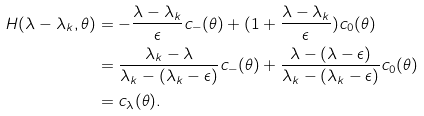<formula> <loc_0><loc_0><loc_500><loc_500>H ( \lambda - \lambda _ { k } , \theta ) & = - \frac { \lambda - \lambda _ { k } } { \epsilon } c _ { - } ( \theta ) + ( 1 + \frac { \lambda - \lambda _ { k } } { \epsilon } ) c _ { 0 } ( \theta ) \\ & = \frac { \lambda _ { k } - \lambda } { \lambda _ { k } - ( \lambda _ { k } - \epsilon ) } c _ { - } ( \theta ) + \frac { \lambda - ( \lambda - \epsilon ) } { \lambda _ { k } - ( \lambda _ { k } - \epsilon ) } c _ { 0 } ( \theta ) \\ & = c _ { \lambda } ( \theta ) .</formula> 